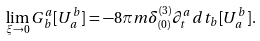<formula> <loc_0><loc_0><loc_500><loc_500>\lim _ { \xi \rightarrow 0 } G ^ { a } _ { \, b } [ U ^ { b } _ { \, a } ] = - 8 \pi m \delta ^ { ( 3 ) } _ { ( 0 ) } { \partial } ^ { a } _ { t } d t _ { b } [ U ^ { b } _ { \, a } ] .</formula> 